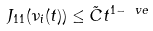Convert formula to latex. <formula><loc_0><loc_0><loc_500><loc_500>J _ { 1 1 } ( \nu _ { i } ( t ) ) \leq \tilde { C } t ^ { 1 - \ v e }</formula> 